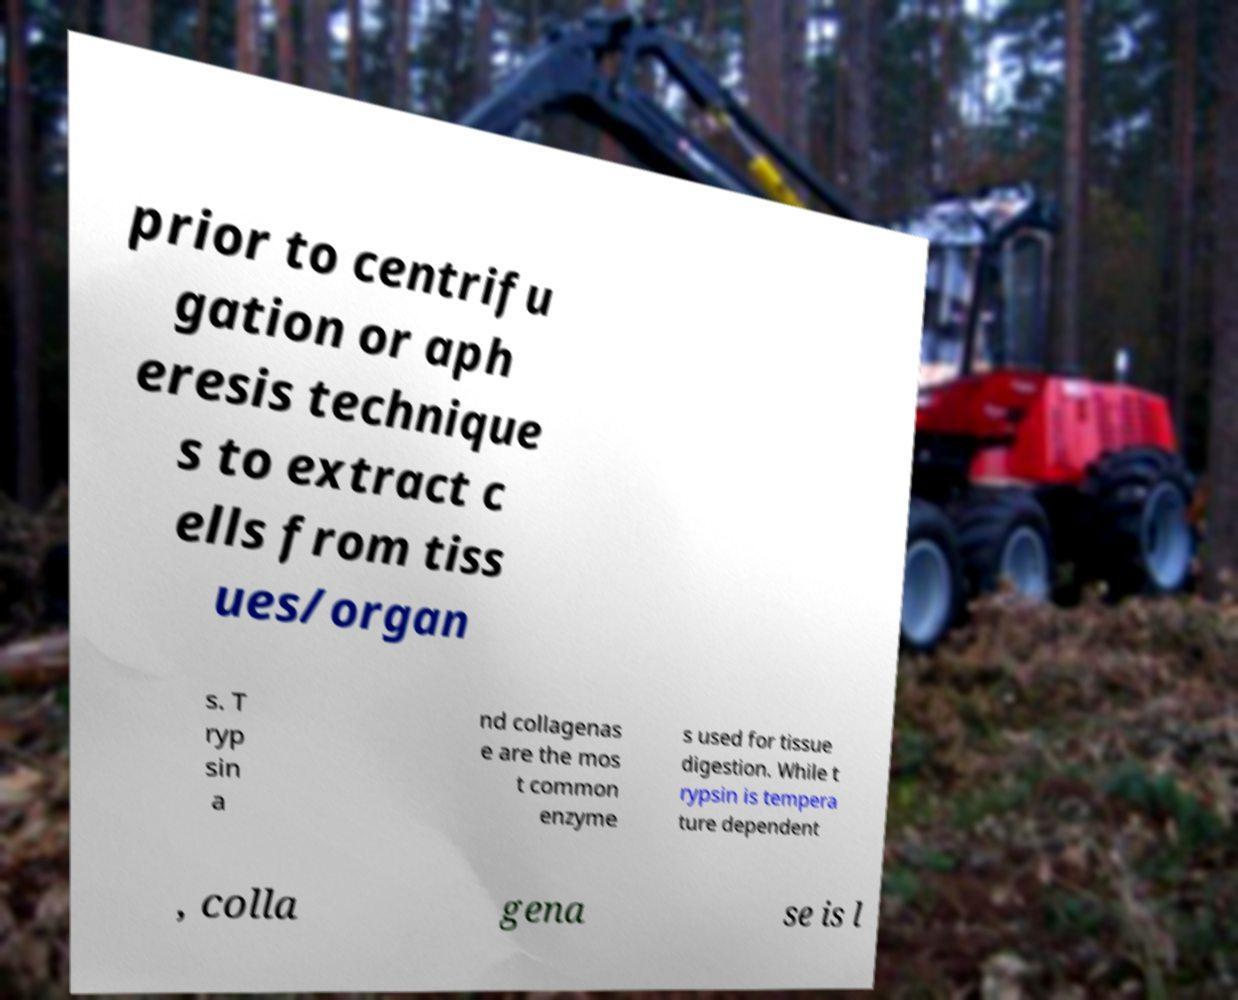Please read and relay the text visible in this image. What does it say? prior to centrifu gation or aph eresis technique s to extract c ells from tiss ues/organ s. T ryp sin a nd collagenas e are the mos t common enzyme s used for tissue digestion. While t rypsin is tempera ture dependent , colla gena se is l 